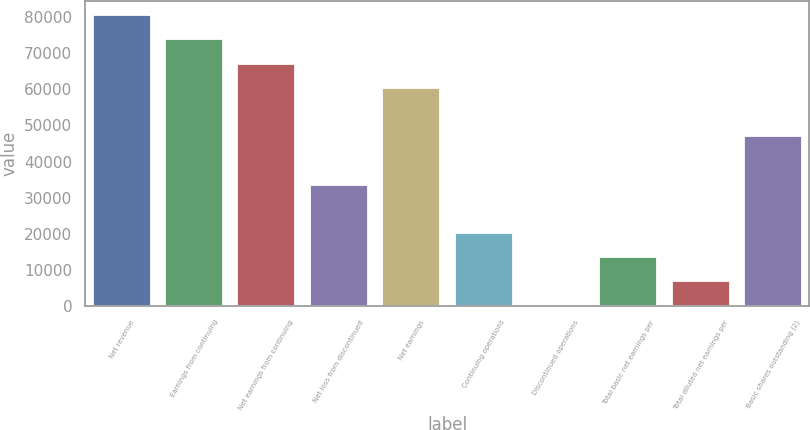Convert chart. <chart><loc_0><loc_0><loc_500><loc_500><bar_chart><fcel>Net revenue<fcel>Earnings from continuing<fcel>Net earnings from continuing<fcel>Net loss from discontinued<fcel>Net earnings<fcel>Continuing operations<fcel>Discontinued operations<fcel>Total basic net earnings per<fcel>Total diluted net earnings per<fcel>Basic shares outstanding (2)<nl><fcel>80588.2<fcel>73872.6<fcel>67157<fcel>33578.8<fcel>60441.3<fcel>20147.5<fcel>0.56<fcel>13431.8<fcel>6716.2<fcel>47010<nl></chart> 